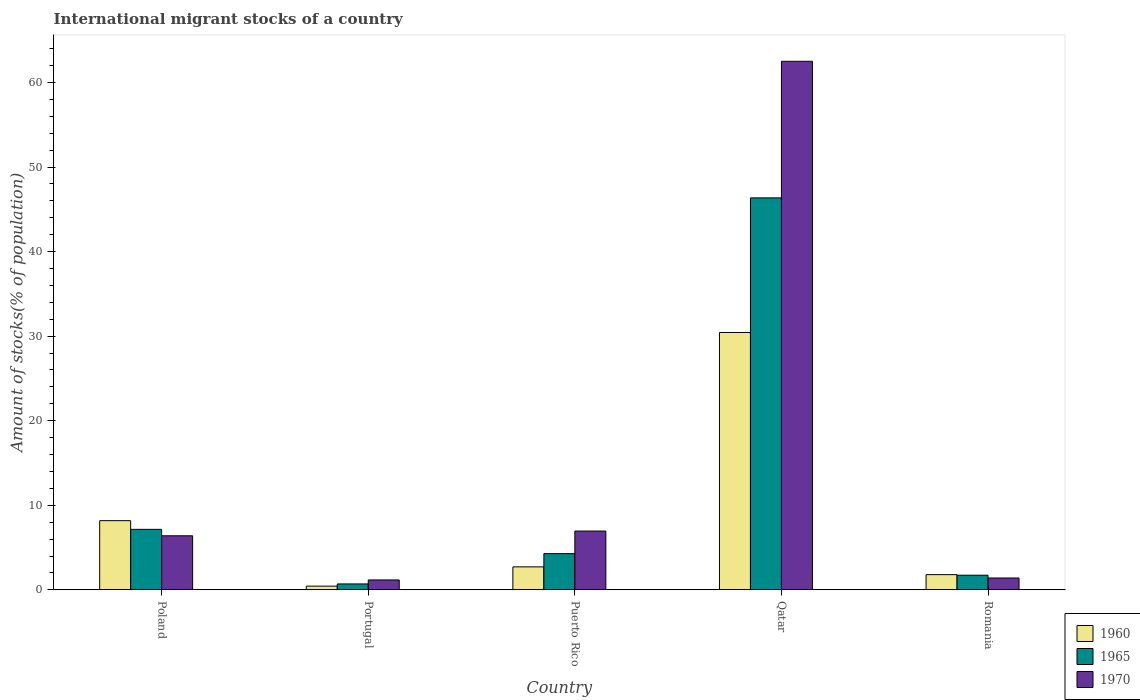How many groups of bars are there?
Your answer should be very brief. 5. Are the number of bars per tick equal to the number of legend labels?
Make the answer very short. Yes. Are the number of bars on each tick of the X-axis equal?
Provide a short and direct response. Yes. How many bars are there on the 5th tick from the right?
Your response must be concise. 3. What is the amount of stocks in in 1965 in Portugal?
Give a very brief answer. 0.7. Across all countries, what is the maximum amount of stocks in in 1970?
Provide a short and direct response. 62.51. Across all countries, what is the minimum amount of stocks in in 1960?
Your response must be concise. 0.44. In which country was the amount of stocks in in 1960 maximum?
Your answer should be very brief. Qatar. What is the total amount of stocks in in 1960 in the graph?
Offer a terse response. 43.57. What is the difference between the amount of stocks in in 1970 in Poland and that in Puerto Rico?
Your answer should be compact. -0.56. What is the difference between the amount of stocks in in 1960 in Portugal and the amount of stocks in in 1970 in Qatar?
Give a very brief answer. -62.07. What is the average amount of stocks in in 1960 per country?
Your answer should be very brief. 8.71. What is the difference between the amount of stocks in of/in 1970 and amount of stocks in of/in 1960 in Puerto Rico?
Give a very brief answer. 4.24. In how many countries, is the amount of stocks in in 1970 greater than 38 %?
Give a very brief answer. 1. What is the ratio of the amount of stocks in in 1960 in Poland to that in Qatar?
Provide a short and direct response. 0.27. Is the difference between the amount of stocks in in 1970 in Poland and Portugal greater than the difference between the amount of stocks in in 1960 in Poland and Portugal?
Keep it short and to the point. No. What is the difference between the highest and the second highest amount of stocks in in 1970?
Offer a terse response. -56.12. What is the difference between the highest and the lowest amount of stocks in in 1970?
Your answer should be very brief. 61.34. In how many countries, is the amount of stocks in in 1970 greater than the average amount of stocks in in 1970 taken over all countries?
Make the answer very short. 1. Is the sum of the amount of stocks in in 1960 in Poland and Qatar greater than the maximum amount of stocks in in 1970 across all countries?
Give a very brief answer. No. Is it the case that in every country, the sum of the amount of stocks in in 1965 and amount of stocks in in 1960 is greater than the amount of stocks in in 1970?
Give a very brief answer. No. Are all the bars in the graph horizontal?
Give a very brief answer. No. How many countries are there in the graph?
Ensure brevity in your answer.  5. What is the difference between two consecutive major ticks on the Y-axis?
Ensure brevity in your answer.  10. Does the graph contain any zero values?
Ensure brevity in your answer.  No. Does the graph contain grids?
Your response must be concise. No. Where does the legend appear in the graph?
Your answer should be compact. Bottom right. What is the title of the graph?
Ensure brevity in your answer.  International migrant stocks of a country. What is the label or title of the Y-axis?
Offer a very short reply. Amount of stocks(% of population). What is the Amount of stocks(% of population) of 1960 in Poland?
Your answer should be compact. 8.18. What is the Amount of stocks(% of population) in 1965 in Poland?
Offer a terse response. 7.15. What is the Amount of stocks(% of population) of 1970 in Poland?
Your answer should be very brief. 6.39. What is the Amount of stocks(% of population) in 1960 in Portugal?
Your answer should be compact. 0.44. What is the Amount of stocks(% of population) of 1965 in Portugal?
Ensure brevity in your answer.  0.7. What is the Amount of stocks(% of population) of 1970 in Portugal?
Offer a very short reply. 1.17. What is the Amount of stocks(% of population) in 1960 in Puerto Rico?
Your response must be concise. 2.72. What is the Amount of stocks(% of population) in 1965 in Puerto Rico?
Offer a terse response. 4.28. What is the Amount of stocks(% of population) in 1970 in Puerto Rico?
Provide a short and direct response. 6.95. What is the Amount of stocks(% of population) of 1960 in Qatar?
Provide a succinct answer. 30.44. What is the Amount of stocks(% of population) of 1965 in Qatar?
Ensure brevity in your answer.  46.36. What is the Amount of stocks(% of population) of 1970 in Qatar?
Offer a terse response. 62.51. What is the Amount of stocks(% of population) in 1960 in Romania?
Your answer should be very brief. 1.8. What is the Amount of stocks(% of population) in 1965 in Romania?
Your answer should be compact. 1.73. What is the Amount of stocks(% of population) in 1970 in Romania?
Make the answer very short. 1.4. Across all countries, what is the maximum Amount of stocks(% of population) in 1960?
Give a very brief answer. 30.44. Across all countries, what is the maximum Amount of stocks(% of population) in 1965?
Offer a very short reply. 46.36. Across all countries, what is the maximum Amount of stocks(% of population) of 1970?
Offer a very short reply. 62.51. Across all countries, what is the minimum Amount of stocks(% of population) of 1960?
Keep it short and to the point. 0.44. Across all countries, what is the minimum Amount of stocks(% of population) in 1965?
Offer a terse response. 0.7. Across all countries, what is the minimum Amount of stocks(% of population) in 1970?
Offer a terse response. 1.17. What is the total Amount of stocks(% of population) of 1960 in the graph?
Give a very brief answer. 43.57. What is the total Amount of stocks(% of population) of 1965 in the graph?
Your answer should be compact. 60.22. What is the total Amount of stocks(% of population) in 1970 in the graph?
Offer a terse response. 78.42. What is the difference between the Amount of stocks(% of population) of 1960 in Poland and that in Portugal?
Your answer should be compact. 7.74. What is the difference between the Amount of stocks(% of population) of 1965 in Poland and that in Portugal?
Offer a terse response. 6.46. What is the difference between the Amount of stocks(% of population) in 1970 in Poland and that in Portugal?
Offer a terse response. 5.22. What is the difference between the Amount of stocks(% of population) in 1960 in Poland and that in Puerto Rico?
Offer a very short reply. 5.46. What is the difference between the Amount of stocks(% of population) of 1965 in Poland and that in Puerto Rico?
Your response must be concise. 2.87. What is the difference between the Amount of stocks(% of population) of 1970 in Poland and that in Puerto Rico?
Provide a succinct answer. -0.56. What is the difference between the Amount of stocks(% of population) of 1960 in Poland and that in Qatar?
Provide a succinct answer. -22.26. What is the difference between the Amount of stocks(% of population) of 1965 in Poland and that in Qatar?
Your response must be concise. -39.2. What is the difference between the Amount of stocks(% of population) in 1970 in Poland and that in Qatar?
Offer a very short reply. -56.12. What is the difference between the Amount of stocks(% of population) in 1960 in Poland and that in Romania?
Offer a terse response. 6.38. What is the difference between the Amount of stocks(% of population) in 1965 in Poland and that in Romania?
Provide a succinct answer. 5.42. What is the difference between the Amount of stocks(% of population) of 1970 in Poland and that in Romania?
Ensure brevity in your answer.  4.99. What is the difference between the Amount of stocks(% of population) of 1960 in Portugal and that in Puerto Rico?
Keep it short and to the point. -2.28. What is the difference between the Amount of stocks(% of population) in 1965 in Portugal and that in Puerto Rico?
Ensure brevity in your answer.  -3.58. What is the difference between the Amount of stocks(% of population) in 1970 in Portugal and that in Puerto Rico?
Keep it short and to the point. -5.78. What is the difference between the Amount of stocks(% of population) in 1960 in Portugal and that in Qatar?
Ensure brevity in your answer.  -30. What is the difference between the Amount of stocks(% of population) in 1965 in Portugal and that in Qatar?
Provide a short and direct response. -45.66. What is the difference between the Amount of stocks(% of population) of 1970 in Portugal and that in Qatar?
Provide a short and direct response. -61.34. What is the difference between the Amount of stocks(% of population) of 1960 in Portugal and that in Romania?
Ensure brevity in your answer.  -1.36. What is the difference between the Amount of stocks(% of population) of 1965 in Portugal and that in Romania?
Provide a short and direct response. -1.03. What is the difference between the Amount of stocks(% of population) in 1970 in Portugal and that in Romania?
Make the answer very short. -0.23. What is the difference between the Amount of stocks(% of population) in 1960 in Puerto Rico and that in Qatar?
Offer a very short reply. -27.72. What is the difference between the Amount of stocks(% of population) in 1965 in Puerto Rico and that in Qatar?
Offer a very short reply. -42.07. What is the difference between the Amount of stocks(% of population) in 1970 in Puerto Rico and that in Qatar?
Offer a terse response. -55.56. What is the difference between the Amount of stocks(% of population) of 1960 in Puerto Rico and that in Romania?
Ensure brevity in your answer.  0.92. What is the difference between the Amount of stocks(% of population) of 1965 in Puerto Rico and that in Romania?
Your answer should be very brief. 2.55. What is the difference between the Amount of stocks(% of population) of 1970 in Puerto Rico and that in Romania?
Provide a succinct answer. 5.55. What is the difference between the Amount of stocks(% of population) of 1960 in Qatar and that in Romania?
Offer a very short reply. 28.64. What is the difference between the Amount of stocks(% of population) of 1965 in Qatar and that in Romania?
Offer a terse response. 44.63. What is the difference between the Amount of stocks(% of population) of 1970 in Qatar and that in Romania?
Provide a short and direct response. 61.11. What is the difference between the Amount of stocks(% of population) in 1960 in Poland and the Amount of stocks(% of population) in 1965 in Portugal?
Your answer should be very brief. 7.48. What is the difference between the Amount of stocks(% of population) of 1960 in Poland and the Amount of stocks(% of population) of 1970 in Portugal?
Your answer should be compact. 7.01. What is the difference between the Amount of stocks(% of population) of 1965 in Poland and the Amount of stocks(% of population) of 1970 in Portugal?
Provide a short and direct response. 5.98. What is the difference between the Amount of stocks(% of population) of 1960 in Poland and the Amount of stocks(% of population) of 1965 in Puerto Rico?
Ensure brevity in your answer.  3.9. What is the difference between the Amount of stocks(% of population) in 1960 in Poland and the Amount of stocks(% of population) in 1970 in Puerto Rico?
Your answer should be compact. 1.23. What is the difference between the Amount of stocks(% of population) of 1965 in Poland and the Amount of stocks(% of population) of 1970 in Puerto Rico?
Your answer should be very brief. 0.2. What is the difference between the Amount of stocks(% of population) in 1960 in Poland and the Amount of stocks(% of population) in 1965 in Qatar?
Keep it short and to the point. -38.17. What is the difference between the Amount of stocks(% of population) in 1960 in Poland and the Amount of stocks(% of population) in 1970 in Qatar?
Give a very brief answer. -54.33. What is the difference between the Amount of stocks(% of population) of 1965 in Poland and the Amount of stocks(% of population) of 1970 in Qatar?
Provide a succinct answer. -55.35. What is the difference between the Amount of stocks(% of population) in 1960 in Poland and the Amount of stocks(% of population) in 1965 in Romania?
Offer a very short reply. 6.45. What is the difference between the Amount of stocks(% of population) of 1960 in Poland and the Amount of stocks(% of population) of 1970 in Romania?
Offer a terse response. 6.78. What is the difference between the Amount of stocks(% of population) of 1965 in Poland and the Amount of stocks(% of population) of 1970 in Romania?
Provide a succinct answer. 5.75. What is the difference between the Amount of stocks(% of population) of 1960 in Portugal and the Amount of stocks(% of population) of 1965 in Puerto Rico?
Offer a terse response. -3.84. What is the difference between the Amount of stocks(% of population) of 1960 in Portugal and the Amount of stocks(% of population) of 1970 in Puerto Rico?
Offer a terse response. -6.51. What is the difference between the Amount of stocks(% of population) in 1965 in Portugal and the Amount of stocks(% of population) in 1970 in Puerto Rico?
Offer a very short reply. -6.25. What is the difference between the Amount of stocks(% of population) of 1960 in Portugal and the Amount of stocks(% of population) of 1965 in Qatar?
Offer a very short reply. -45.92. What is the difference between the Amount of stocks(% of population) in 1960 in Portugal and the Amount of stocks(% of population) in 1970 in Qatar?
Your answer should be very brief. -62.07. What is the difference between the Amount of stocks(% of population) of 1965 in Portugal and the Amount of stocks(% of population) of 1970 in Qatar?
Keep it short and to the point. -61.81. What is the difference between the Amount of stocks(% of population) in 1960 in Portugal and the Amount of stocks(% of population) in 1965 in Romania?
Give a very brief answer. -1.29. What is the difference between the Amount of stocks(% of population) of 1960 in Portugal and the Amount of stocks(% of population) of 1970 in Romania?
Ensure brevity in your answer.  -0.96. What is the difference between the Amount of stocks(% of population) of 1965 in Portugal and the Amount of stocks(% of population) of 1970 in Romania?
Your response must be concise. -0.7. What is the difference between the Amount of stocks(% of population) of 1960 in Puerto Rico and the Amount of stocks(% of population) of 1965 in Qatar?
Your response must be concise. -43.64. What is the difference between the Amount of stocks(% of population) in 1960 in Puerto Rico and the Amount of stocks(% of population) in 1970 in Qatar?
Give a very brief answer. -59.79. What is the difference between the Amount of stocks(% of population) of 1965 in Puerto Rico and the Amount of stocks(% of population) of 1970 in Qatar?
Provide a succinct answer. -58.23. What is the difference between the Amount of stocks(% of population) of 1960 in Puerto Rico and the Amount of stocks(% of population) of 1965 in Romania?
Make the answer very short. 0.99. What is the difference between the Amount of stocks(% of population) in 1960 in Puerto Rico and the Amount of stocks(% of population) in 1970 in Romania?
Give a very brief answer. 1.32. What is the difference between the Amount of stocks(% of population) in 1965 in Puerto Rico and the Amount of stocks(% of population) in 1970 in Romania?
Your answer should be compact. 2.88. What is the difference between the Amount of stocks(% of population) of 1960 in Qatar and the Amount of stocks(% of population) of 1965 in Romania?
Provide a succinct answer. 28.71. What is the difference between the Amount of stocks(% of population) of 1960 in Qatar and the Amount of stocks(% of population) of 1970 in Romania?
Provide a short and direct response. 29.04. What is the difference between the Amount of stocks(% of population) of 1965 in Qatar and the Amount of stocks(% of population) of 1970 in Romania?
Ensure brevity in your answer.  44.95. What is the average Amount of stocks(% of population) in 1960 per country?
Your answer should be compact. 8.71. What is the average Amount of stocks(% of population) of 1965 per country?
Provide a short and direct response. 12.04. What is the average Amount of stocks(% of population) of 1970 per country?
Your answer should be very brief. 15.68. What is the difference between the Amount of stocks(% of population) in 1960 and Amount of stocks(% of population) in 1965 in Poland?
Your response must be concise. 1.03. What is the difference between the Amount of stocks(% of population) of 1960 and Amount of stocks(% of population) of 1970 in Poland?
Give a very brief answer. 1.79. What is the difference between the Amount of stocks(% of population) in 1965 and Amount of stocks(% of population) in 1970 in Poland?
Your answer should be very brief. 0.76. What is the difference between the Amount of stocks(% of population) in 1960 and Amount of stocks(% of population) in 1965 in Portugal?
Provide a short and direct response. -0.26. What is the difference between the Amount of stocks(% of population) in 1960 and Amount of stocks(% of population) in 1970 in Portugal?
Offer a terse response. -0.73. What is the difference between the Amount of stocks(% of population) in 1965 and Amount of stocks(% of population) in 1970 in Portugal?
Your answer should be compact. -0.47. What is the difference between the Amount of stocks(% of population) of 1960 and Amount of stocks(% of population) of 1965 in Puerto Rico?
Your answer should be compact. -1.56. What is the difference between the Amount of stocks(% of population) in 1960 and Amount of stocks(% of population) in 1970 in Puerto Rico?
Your answer should be very brief. -4.24. What is the difference between the Amount of stocks(% of population) of 1965 and Amount of stocks(% of population) of 1970 in Puerto Rico?
Offer a terse response. -2.67. What is the difference between the Amount of stocks(% of population) of 1960 and Amount of stocks(% of population) of 1965 in Qatar?
Offer a terse response. -15.92. What is the difference between the Amount of stocks(% of population) of 1960 and Amount of stocks(% of population) of 1970 in Qatar?
Make the answer very short. -32.07. What is the difference between the Amount of stocks(% of population) in 1965 and Amount of stocks(% of population) in 1970 in Qatar?
Provide a short and direct response. -16.15. What is the difference between the Amount of stocks(% of population) in 1960 and Amount of stocks(% of population) in 1965 in Romania?
Provide a short and direct response. 0.07. What is the difference between the Amount of stocks(% of population) in 1960 and Amount of stocks(% of population) in 1970 in Romania?
Give a very brief answer. 0.4. What is the difference between the Amount of stocks(% of population) of 1965 and Amount of stocks(% of population) of 1970 in Romania?
Keep it short and to the point. 0.33. What is the ratio of the Amount of stocks(% of population) of 1960 in Poland to that in Portugal?
Provide a succinct answer. 18.63. What is the ratio of the Amount of stocks(% of population) in 1965 in Poland to that in Portugal?
Offer a terse response. 10.24. What is the ratio of the Amount of stocks(% of population) of 1970 in Poland to that in Portugal?
Make the answer very short. 5.46. What is the ratio of the Amount of stocks(% of population) in 1960 in Poland to that in Puerto Rico?
Offer a very short reply. 3.01. What is the ratio of the Amount of stocks(% of population) in 1965 in Poland to that in Puerto Rico?
Provide a short and direct response. 1.67. What is the ratio of the Amount of stocks(% of population) in 1970 in Poland to that in Puerto Rico?
Offer a terse response. 0.92. What is the ratio of the Amount of stocks(% of population) of 1960 in Poland to that in Qatar?
Your answer should be compact. 0.27. What is the ratio of the Amount of stocks(% of population) in 1965 in Poland to that in Qatar?
Your response must be concise. 0.15. What is the ratio of the Amount of stocks(% of population) of 1970 in Poland to that in Qatar?
Offer a very short reply. 0.1. What is the ratio of the Amount of stocks(% of population) in 1960 in Poland to that in Romania?
Provide a short and direct response. 4.55. What is the ratio of the Amount of stocks(% of population) of 1965 in Poland to that in Romania?
Provide a succinct answer. 4.14. What is the ratio of the Amount of stocks(% of population) of 1970 in Poland to that in Romania?
Keep it short and to the point. 4.56. What is the ratio of the Amount of stocks(% of population) in 1960 in Portugal to that in Puerto Rico?
Ensure brevity in your answer.  0.16. What is the ratio of the Amount of stocks(% of population) in 1965 in Portugal to that in Puerto Rico?
Keep it short and to the point. 0.16. What is the ratio of the Amount of stocks(% of population) of 1970 in Portugal to that in Puerto Rico?
Provide a succinct answer. 0.17. What is the ratio of the Amount of stocks(% of population) of 1960 in Portugal to that in Qatar?
Make the answer very short. 0.01. What is the ratio of the Amount of stocks(% of population) of 1965 in Portugal to that in Qatar?
Offer a very short reply. 0.02. What is the ratio of the Amount of stocks(% of population) in 1970 in Portugal to that in Qatar?
Your response must be concise. 0.02. What is the ratio of the Amount of stocks(% of population) in 1960 in Portugal to that in Romania?
Your answer should be compact. 0.24. What is the ratio of the Amount of stocks(% of population) of 1965 in Portugal to that in Romania?
Keep it short and to the point. 0.4. What is the ratio of the Amount of stocks(% of population) in 1970 in Portugal to that in Romania?
Provide a succinct answer. 0.84. What is the ratio of the Amount of stocks(% of population) of 1960 in Puerto Rico to that in Qatar?
Offer a terse response. 0.09. What is the ratio of the Amount of stocks(% of population) in 1965 in Puerto Rico to that in Qatar?
Offer a terse response. 0.09. What is the ratio of the Amount of stocks(% of population) in 1970 in Puerto Rico to that in Qatar?
Your answer should be compact. 0.11. What is the ratio of the Amount of stocks(% of population) of 1960 in Puerto Rico to that in Romania?
Your answer should be compact. 1.51. What is the ratio of the Amount of stocks(% of population) of 1965 in Puerto Rico to that in Romania?
Give a very brief answer. 2.47. What is the ratio of the Amount of stocks(% of population) in 1970 in Puerto Rico to that in Romania?
Provide a succinct answer. 4.96. What is the ratio of the Amount of stocks(% of population) of 1960 in Qatar to that in Romania?
Ensure brevity in your answer.  16.93. What is the ratio of the Amount of stocks(% of population) of 1965 in Qatar to that in Romania?
Keep it short and to the point. 26.8. What is the ratio of the Amount of stocks(% of population) of 1970 in Qatar to that in Romania?
Ensure brevity in your answer.  44.6. What is the difference between the highest and the second highest Amount of stocks(% of population) of 1960?
Give a very brief answer. 22.26. What is the difference between the highest and the second highest Amount of stocks(% of population) in 1965?
Your answer should be compact. 39.2. What is the difference between the highest and the second highest Amount of stocks(% of population) in 1970?
Your answer should be compact. 55.56. What is the difference between the highest and the lowest Amount of stocks(% of population) in 1960?
Your answer should be very brief. 30. What is the difference between the highest and the lowest Amount of stocks(% of population) of 1965?
Offer a terse response. 45.66. What is the difference between the highest and the lowest Amount of stocks(% of population) of 1970?
Your answer should be very brief. 61.34. 